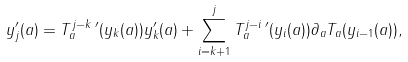<formula> <loc_0><loc_0><loc_500><loc_500>y _ { j } ^ { \prime } ( a ) = T _ { a } ^ { j - k } \, ^ { \prime } ( y _ { k } ( a ) ) y _ { k } ^ { \prime } ( a ) + \sum _ { i = k + 1 } ^ { j } T _ { a } ^ { j - i } \, ^ { \prime } ( y _ { i } ( a ) ) \partial _ { a } T _ { a } ( y _ { i - 1 } ( a ) ) ,</formula> 